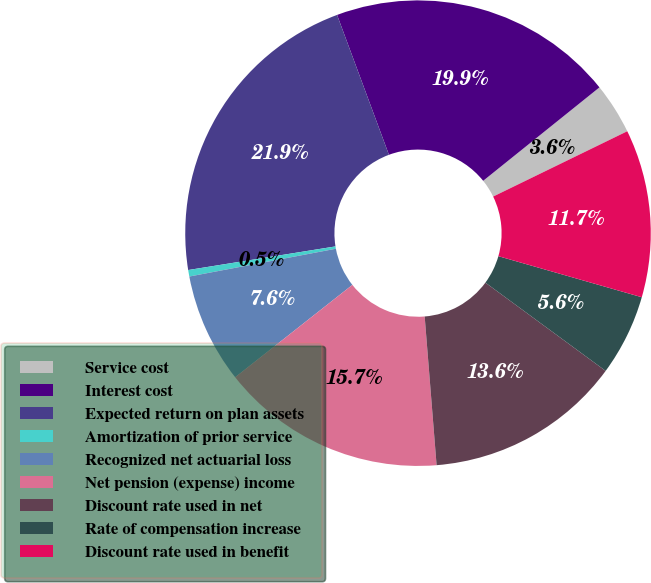<chart> <loc_0><loc_0><loc_500><loc_500><pie_chart><fcel>Service cost<fcel>Interest cost<fcel>Expected return on plan assets<fcel>Amortization of prior service<fcel>Recognized net actuarial loss<fcel>Net pension (expense) income<fcel>Discount rate used in net<fcel>Rate of compensation increase<fcel>Discount rate used in benefit<nl><fcel>3.56%<fcel>19.88%<fcel>21.88%<fcel>0.45%<fcel>7.64%<fcel>15.65%<fcel>13.65%<fcel>5.64%<fcel>11.65%<nl></chart> 